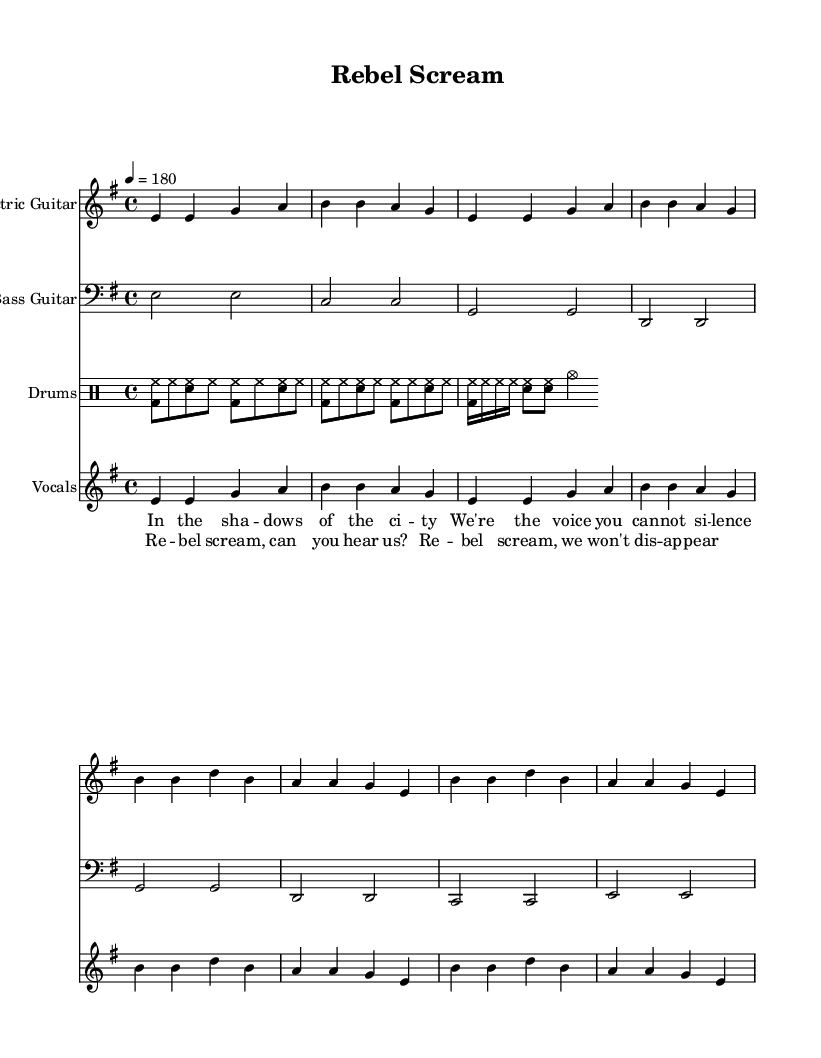What is the key signature of this music? The key signature is indicated at the beginning of the sheet music, where it shows one sharp (F#) on the staff. This corresponds to the E minor key signature.
Answer: E minor What is the time signature of this music? The time signature is located at the beginning of the sheet music, where it shows a 4 over 4, which means there are four beats in a measure and the quarter note gets one beat.
Answer: 4/4 What is the tempo marking for this piece? The tempo marking is indicated at the beginning of the sheet music. It shows a quarter note equals 180 beats per minute, dictating how fast the piece should be played.
Answer: 180 How many measures are in the verse section? To determine this, we can count the number of measures in the verse part of the music, which is labeled in the section for both the electric guitar and vocals. There are 4 measures.
Answer: 4 What types of instruments are included in this score? By looking at the headers for each staff in the score, we can identify the instruments present: Electric Guitar, Bass Guitar, Drums, and Vocals.
Answer: Electric Guitar, Bass Guitar, Drums, Vocals How many times does the chorus repeat? The chorus section of the music can be identified in the vocal part where lyrics are first presented. By counting the measures and the specific sections of lyrics, we see that the chorus appears once after the verse.
Answer: 1 